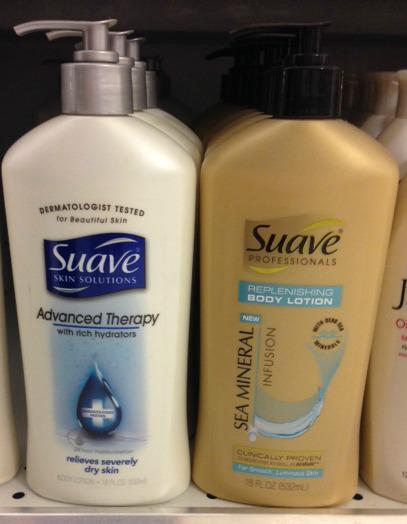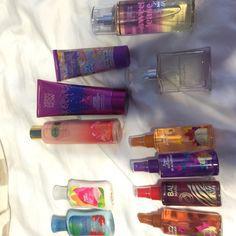The first image is the image on the left, the second image is the image on the right. Assess this claim about the two images: "An image shows only pump-top products.". Correct or not? Answer yes or no. Yes. The first image is the image on the left, the second image is the image on the right. For the images displayed, is the sentence "Two bottles of lotion stand together in the image on the left." factually correct? Answer yes or no. Yes. 